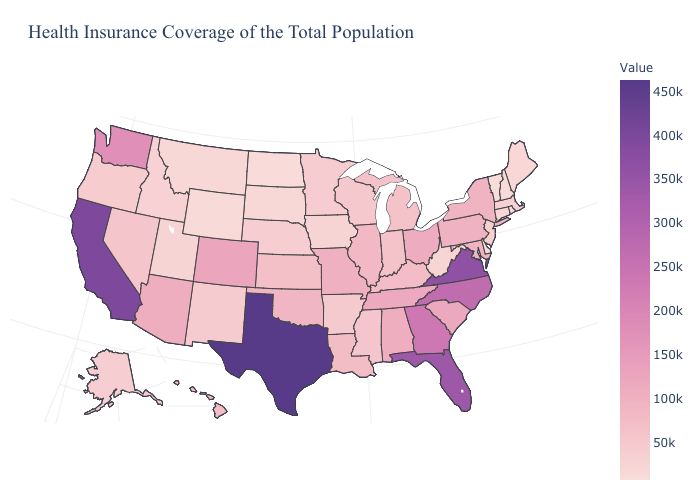Which states have the highest value in the USA?
Answer briefly. Texas. Among the states that border Arkansas , which have the highest value?
Write a very short answer. Texas. Which states have the lowest value in the Northeast?
Write a very short answer. Vermont. Which states have the lowest value in the USA?
Be succinct. Vermont. Among the states that border Utah , which have the lowest value?
Answer briefly. Wyoming. 